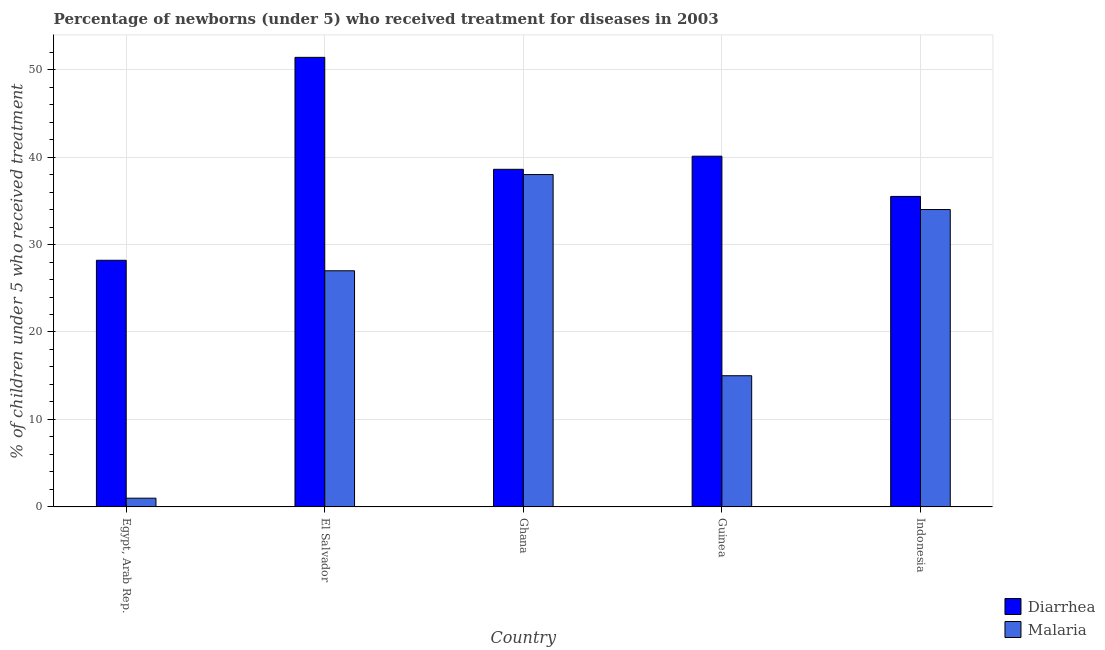How many bars are there on the 4th tick from the left?
Your response must be concise. 2. How many bars are there on the 2nd tick from the right?
Provide a succinct answer. 2. What is the label of the 4th group of bars from the left?
Your answer should be very brief. Guinea. In how many cases, is the number of bars for a given country not equal to the number of legend labels?
Keep it short and to the point. 0. Across all countries, what is the maximum percentage of children who received treatment for malaria?
Give a very brief answer. 38. Across all countries, what is the minimum percentage of children who received treatment for diarrhoea?
Your answer should be compact. 28.2. In which country was the percentage of children who received treatment for malaria maximum?
Your answer should be very brief. Ghana. In which country was the percentage of children who received treatment for malaria minimum?
Make the answer very short. Egypt, Arab Rep. What is the total percentage of children who received treatment for diarrhoea in the graph?
Provide a short and direct response. 193.8. What is the difference between the percentage of children who received treatment for diarrhoea in Egypt, Arab Rep. and that in Indonesia?
Make the answer very short. -7.3. What is the difference between the percentage of children who received treatment for malaria in El Salvador and the percentage of children who received treatment for diarrhoea in Guinea?
Keep it short and to the point. -13.1. What is the average percentage of children who received treatment for malaria per country?
Your response must be concise. 23. What is the difference between the percentage of children who received treatment for diarrhoea and percentage of children who received treatment for malaria in Indonesia?
Your response must be concise. 1.5. In how many countries, is the percentage of children who received treatment for malaria greater than 20 %?
Offer a terse response. 3. What is the ratio of the percentage of children who received treatment for diarrhoea in Egypt, Arab Rep. to that in El Salvador?
Offer a terse response. 0.55. Is the percentage of children who received treatment for diarrhoea in El Salvador less than that in Guinea?
Keep it short and to the point. No. Is the difference between the percentage of children who received treatment for diarrhoea in Egypt, Arab Rep. and Indonesia greater than the difference between the percentage of children who received treatment for malaria in Egypt, Arab Rep. and Indonesia?
Your response must be concise. Yes. What is the difference between the highest and the second highest percentage of children who received treatment for malaria?
Your answer should be very brief. 4. What is the difference between the highest and the lowest percentage of children who received treatment for diarrhoea?
Ensure brevity in your answer.  23.2. What does the 1st bar from the left in Guinea represents?
Your answer should be compact. Diarrhea. What does the 2nd bar from the right in Indonesia represents?
Your response must be concise. Diarrhea. What is the difference between two consecutive major ticks on the Y-axis?
Give a very brief answer. 10. How are the legend labels stacked?
Ensure brevity in your answer.  Vertical. What is the title of the graph?
Provide a short and direct response. Percentage of newborns (under 5) who received treatment for diseases in 2003. Does "Savings" appear as one of the legend labels in the graph?
Your response must be concise. No. What is the label or title of the Y-axis?
Provide a short and direct response. % of children under 5 who received treatment. What is the % of children under 5 who received treatment of Diarrhea in Egypt, Arab Rep.?
Provide a short and direct response. 28.2. What is the % of children under 5 who received treatment of Diarrhea in El Salvador?
Offer a very short reply. 51.4. What is the % of children under 5 who received treatment in Diarrhea in Ghana?
Offer a very short reply. 38.6. What is the % of children under 5 who received treatment of Diarrhea in Guinea?
Your answer should be very brief. 40.1. What is the % of children under 5 who received treatment of Malaria in Guinea?
Ensure brevity in your answer.  15. What is the % of children under 5 who received treatment in Diarrhea in Indonesia?
Offer a very short reply. 35.5. Across all countries, what is the maximum % of children under 5 who received treatment in Diarrhea?
Your answer should be compact. 51.4. Across all countries, what is the maximum % of children under 5 who received treatment of Malaria?
Provide a succinct answer. 38. Across all countries, what is the minimum % of children under 5 who received treatment in Diarrhea?
Provide a short and direct response. 28.2. What is the total % of children under 5 who received treatment of Diarrhea in the graph?
Give a very brief answer. 193.8. What is the total % of children under 5 who received treatment of Malaria in the graph?
Offer a terse response. 115. What is the difference between the % of children under 5 who received treatment of Diarrhea in Egypt, Arab Rep. and that in El Salvador?
Your answer should be very brief. -23.2. What is the difference between the % of children under 5 who received treatment in Diarrhea in Egypt, Arab Rep. and that in Ghana?
Your answer should be compact. -10.4. What is the difference between the % of children under 5 who received treatment in Malaria in Egypt, Arab Rep. and that in Ghana?
Provide a short and direct response. -37. What is the difference between the % of children under 5 who received treatment of Malaria in Egypt, Arab Rep. and that in Indonesia?
Provide a short and direct response. -33. What is the difference between the % of children under 5 who received treatment of Diarrhea in El Salvador and that in Guinea?
Offer a terse response. 11.3. What is the difference between the % of children under 5 who received treatment in Malaria in El Salvador and that in Guinea?
Your answer should be compact. 12. What is the difference between the % of children under 5 who received treatment in Diarrhea in Ghana and that in Guinea?
Give a very brief answer. -1.5. What is the difference between the % of children under 5 who received treatment of Malaria in Ghana and that in Guinea?
Keep it short and to the point. 23. What is the difference between the % of children under 5 who received treatment of Malaria in Ghana and that in Indonesia?
Offer a terse response. 4. What is the difference between the % of children under 5 who received treatment in Diarrhea in Egypt, Arab Rep. and the % of children under 5 who received treatment in Malaria in Ghana?
Provide a short and direct response. -9.8. What is the difference between the % of children under 5 who received treatment in Diarrhea in Egypt, Arab Rep. and the % of children under 5 who received treatment in Malaria in Guinea?
Your response must be concise. 13.2. What is the difference between the % of children under 5 who received treatment of Diarrhea in El Salvador and the % of children under 5 who received treatment of Malaria in Ghana?
Your answer should be very brief. 13.4. What is the difference between the % of children under 5 who received treatment of Diarrhea in El Salvador and the % of children under 5 who received treatment of Malaria in Guinea?
Give a very brief answer. 36.4. What is the difference between the % of children under 5 who received treatment of Diarrhea in Ghana and the % of children under 5 who received treatment of Malaria in Guinea?
Make the answer very short. 23.6. What is the difference between the % of children under 5 who received treatment of Diarrhea in Guinea and the % of children under 5 who received treatment of Malaria in Indonesia?
Your answer should be compact. 6.1. What is the average % of children under 5 who received treatment in Diarrhea per country?
Your answer should be very brief. 38.76. What is the difference between the % of children under 5 who received treatment in Diarrhea and % of children under 5 who received treatment in Malaria in Egypt, Arab Rep.?
Give a very brief answer. 27.2. What is the difference between the % of children under 5 who received treatment in Diarrhea and % of children under 5 who received treatment in Malaria in El Salvador?
Ensure brevity in your answer.  24.4. What is the difference between the % of children under 5 who received treatment in Diarrhea and % of children under 5 who received treatment in Malaria in Guinea?
Ensure brevity in your answer.  25.1. What is the difference between the % of children under 5 who received treatment of Diarrhea and % of children under 5 who received treatment of Malaria in Indonesia?
Make the answer very short. 1.5. What is the ratio of the % of children under 5 who received treatment in Diarrhea in Egypt, Arab Rep. to that in El Salvador?
Offer a very short reply. 0.55. What is the ratio of the % of children under 5 who received treatment in Malaria in Egypt, Arab Rep. to that in El Salvador?
Ensure brevity in your answer.  0.04. What is the ratio of the % of children under 5 who received treatment in Diarrhea in Egypt, Arab Rep. to that in Ghana?
Make the answer very short. 0.73. What is the ratio of the % of children under 5 who received treatment of Malaria in Egypt, Arab Rep. to that in Ghana?
Make the answer very short. 0.03. What is the ratio of the % of children under 5 who received treatment of Diarrhea in Egypt, Arab Rep. to that in Guinea?
Your answer should be very brief. 0.7. What is the ratio of the % of children under 5 who received treatment of Malaria in Egypt, Arab Rep. to that in Guinea?
Your answer should be compact. 0.07. What is the ratio of the % of children under 5 who received treatment in Diarrhea in Egypt, Arab Rep. to that in Indonesia?
Give a very brief answer. 0.79. What is the ratio of the % of children under 5 who received treatment of Malaria in Egypt, Arab Rep. to that in Indonesia?
Make the answer very short. 0.03. What is the ratio of the % of children under 5 who received treatment in Diarrhea in El Salvador to that in Ghana?
Offer a terse response. 1.33. What is the ratio of the % of children under 5 who received treatment of Malaria in El Salvador to that in Ghana?
Offer a very short reply. 0.71. What is the ratio of the % of children under 5 who received treatment in Diarrhea in El Salvador to that in Guinea?
Your response must be concise. 1.28. What is the ratio of the % of children under 5 who received treatment of Diarrhea in El Salvador to that in Indonesia?
Provide a succinct answer. 1.45. What is the ratio of the % of children under 5 who received treatment of Malaria in El Salvador to that in Indonesia?
Make the answer very short. 0.79. What is the ratio of the % of children under 5 who received treatment of Diarrhea in Ghana to that in Guinea?
Offer a very short reply. 0.96. What is the ratio of the % of children under 5 who received treatment in Malaria in Ghana to that in Guinea?
Your answer should be compact. 2.53. What is the ratio of the % of children under 5 who received treatment in Diarrhea in Ghana to that in Indonesia?
Offer a terse response. 1.09. What is the ratio of the % of children under 5 who received treatment of Malaria in Ghana to that in Indonesia?
Provide a short and direct response. 1.12. What is the ratio of the % of children under 5 who received treatment of Diarrhea in Guinea to that in Indonesia?
Provide a succinct answer. 1.13. What is the ratio of the % of children under 5 who received treatment of Malaria in Guinea to that in Indonesia?
Ensure brevity in your answer.  0.44. What is the difference between the highest and the second highest % of children under 5 who received treatment in Malaria?
Provide a short and direct response. 4. What is the difference between the highest and the lowest % of children under 5 who received treatment of Diarrhea?
Your answer should be very brief. 23.2. What is the difference between the highest and the lowest % of children under 5 who received treatment in Malaria?
Give a very brief answer. 37. 